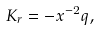Convert formula to latex. <formula><loc_0><loc_0><loc_500><loc_500>K _ { r } = - x ^ { - 2 } q ,</formula> 